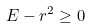Convert formula to latex. <formula><loc_0><loc_0><loc_500><loc_500>E - r ^ { 2 } \geq 0</formula> 